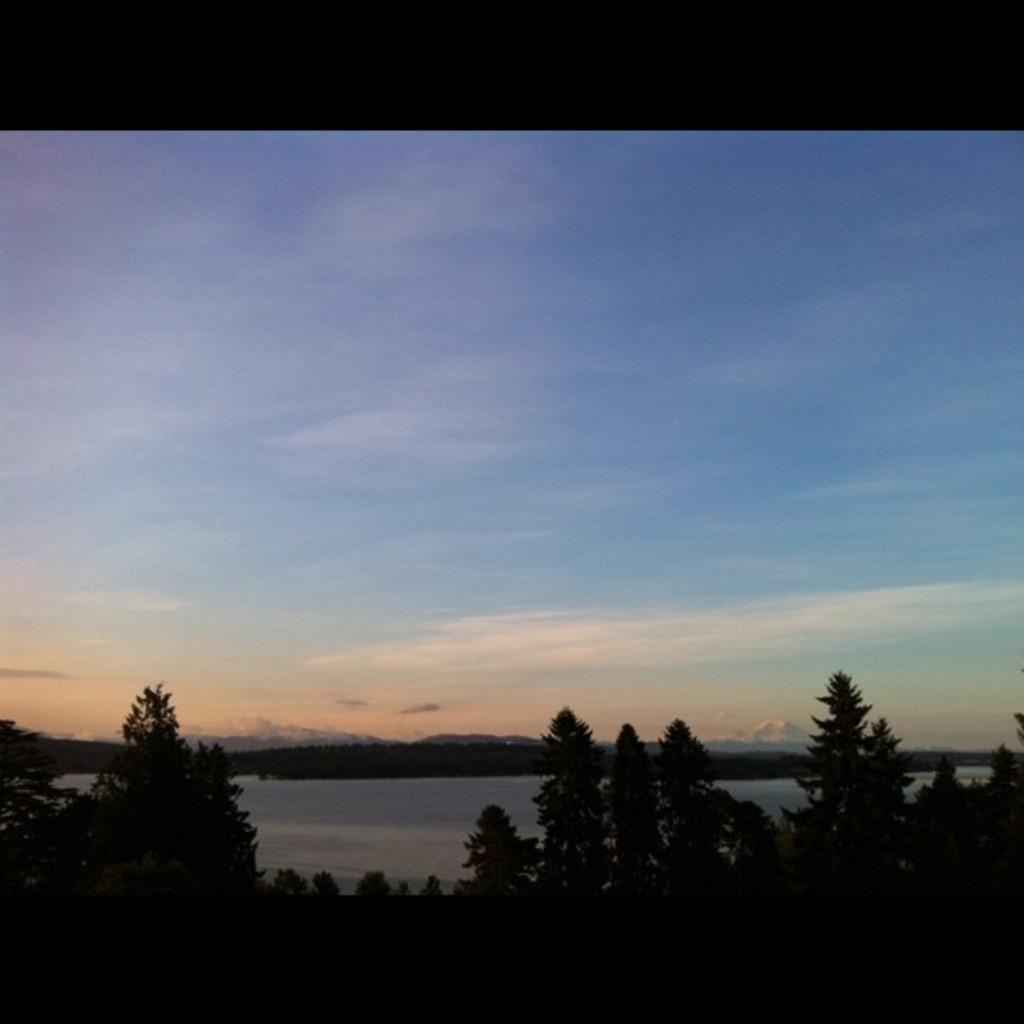What type of vegetation can be seen in the image? There are trees in the image. What type of geographical feature is present in the image? There are hills in the image. What can be seen in the sky in the image? There are clouds in the image. What type of operation is being performed on the trees in the image? There is no operation being performed on the trees in the image; they are simply standing. What is the level of love expressed by the clouds in the image? The clouds in the image do not express love, as they are inanimate objects. 